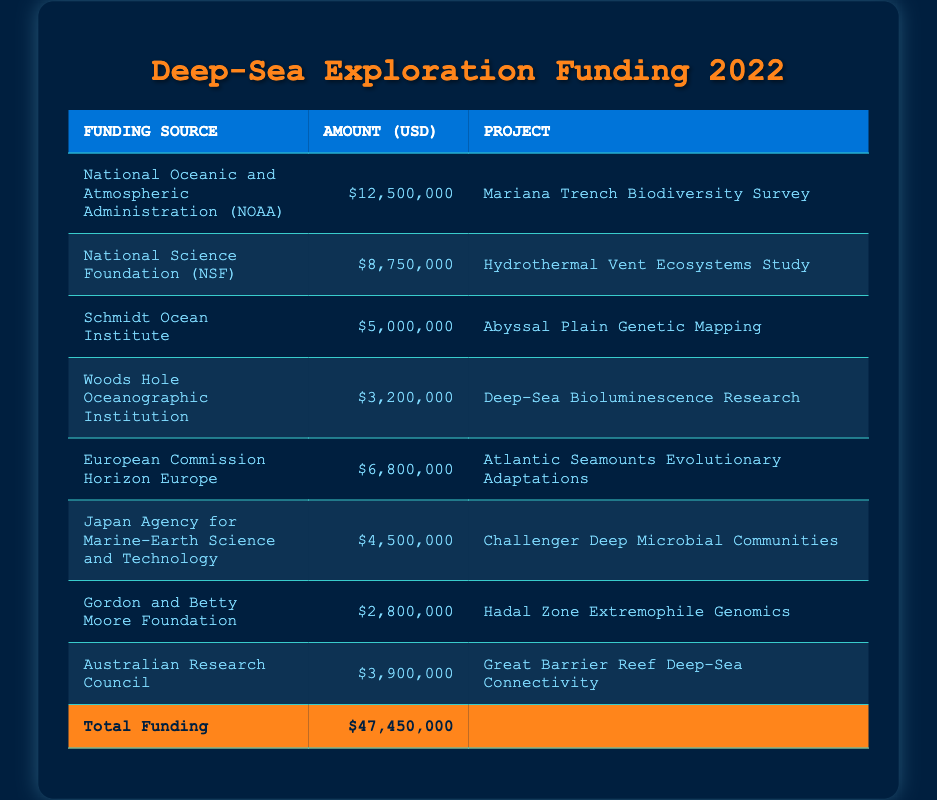What is the total funding allocated for deep-sea exploration projects in 2022? The total funding is listed in the table's footer as $47,450,000.
Answer: 47,450,000 Which funding source provided the highest amount of funding? The National Oceanic and Atmospheric Administration (NOAA) provided the highest amount, which is $12,500,000, as seen in the first row of the table.
Answer: National Oceanic and Atmospheric Administration (NOAA) What project received $5,000,000 in funding? The project that received $5,000,000 in funding is the "Abyssal Plain Genetic Mapping," found in the third row of the table.
Answer: Abyssal Plain Genetic Mapping How much funding did the European Commission Horizon Europe provide compared to the Woods Hole Oceanographic Institution? The European Commission Horizon Europe provided $6,800,000 while the Woods Hole Oceanographic Institution provided $3,200,000. The difference is calculated as $6,800,000 - $3,200,000 = $3,600,000.
Answer: 3,600,000 Is the amount provided by the Japan Agency for Marine-Earth Science and Technology greater than the total provided by the Gordon and Betty Moore Foundation and the Australian Research Council combined? The Japan Agency for Marine-Earth Science and Technology provided $4,500,000. The combined funding from the Gordon and Betty Moore Foundation ($2,800,000) and the Australian Research Council ($3,900,000) is $2,800,000 + $3,900,000 = $6,700,000. Since $4,500,000 is less than $6,700,000, the statement is false.
Answer: No 